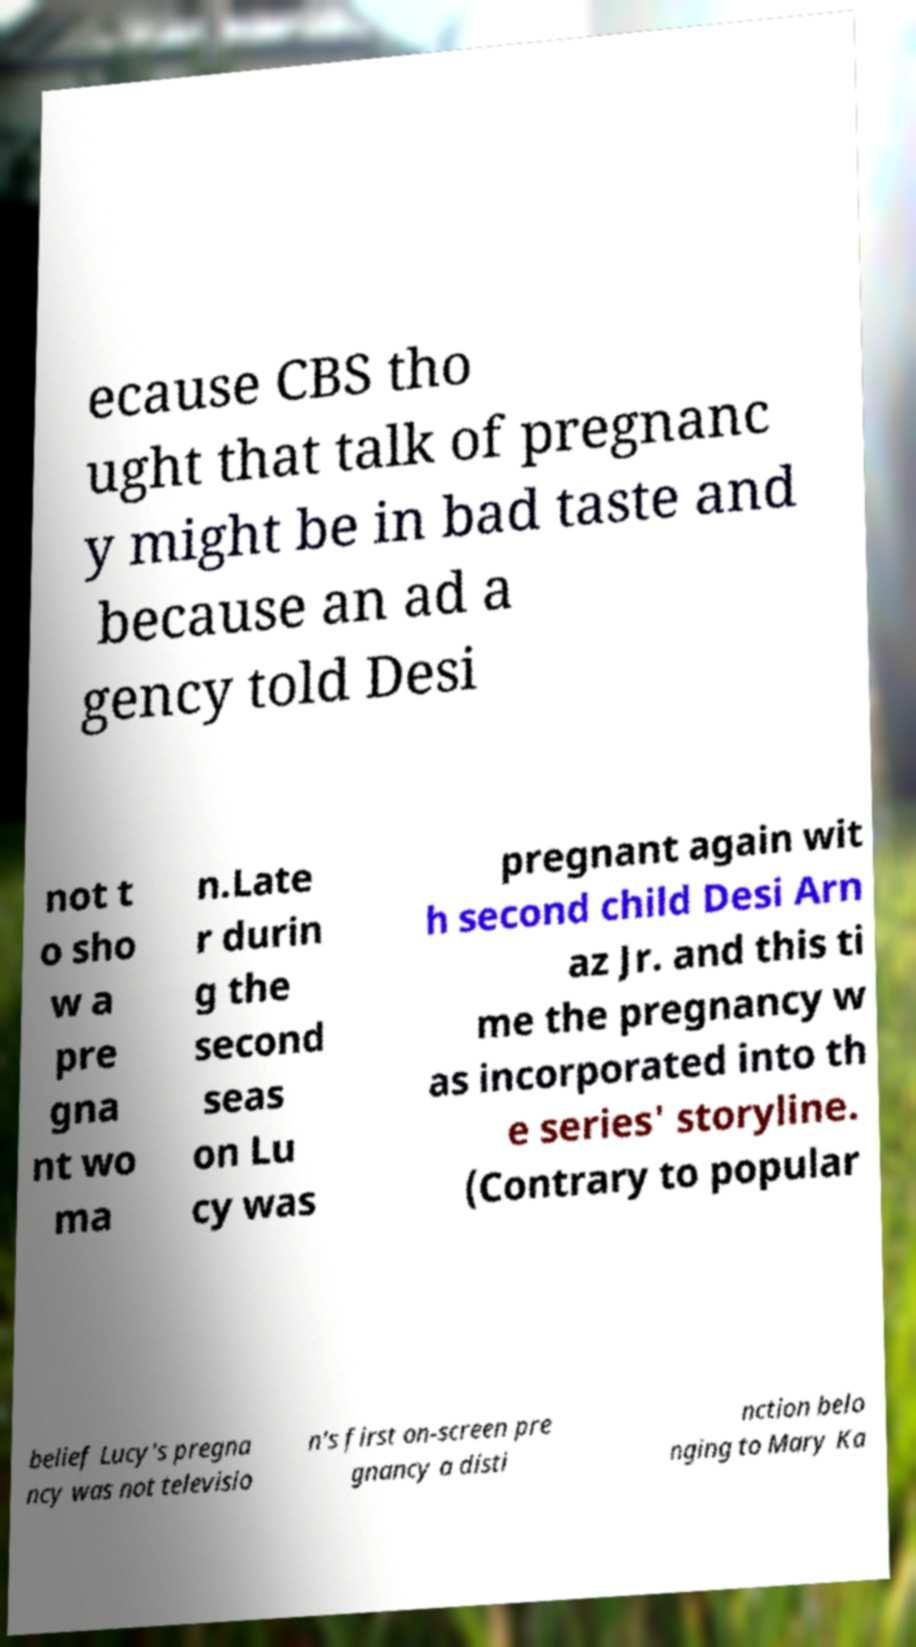Please identify and transcribe the text found in this image. ecause CBS tho ught that talk of pregnanc y might be in bad taste and because an ad a gency told Desi not t o sho w a pre gna nt wo ma n.Late r durin g the second seas on Lu cy was pregnant again wit h second child Desi Arn az Jr. and this ti me the pregnancy w as incorporated into th e series' storyline. (Contrary to popular belief Lucy's pregna ncy was not televisio n's first on-screen pre gnancy a disti nction belo nging to Mary Ka 